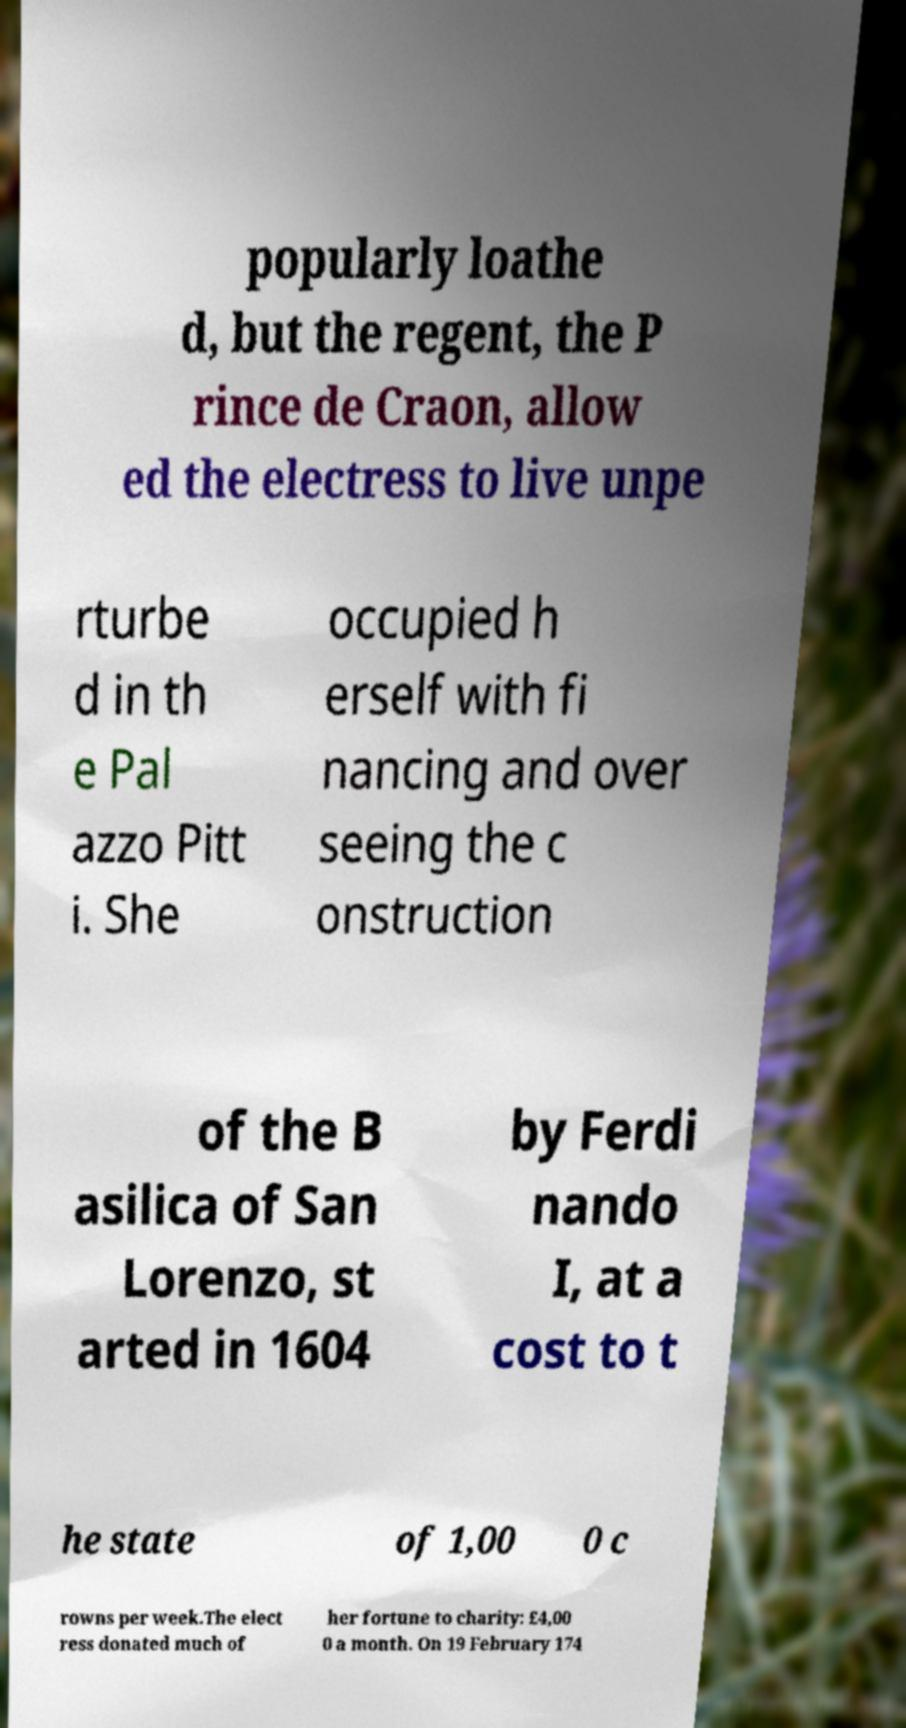Can you accurately transcribe the text from the provided image for me? popularly loathe d, but the regent, the P rince de Craon, allow ed the electress to live unpe rturbe d in th e Pal azzo Pitt i. She occupied h erself with fi nancing and over seeing the c onstruction of the B asilica of San Lorenzo, st arted in 1604 by Ferdi nando I, at a cost to t he state of 1,00 0 c rowns per week.The elect ress donated much of her fortune to charity: £4,00 0 a month. On 19 February 174 